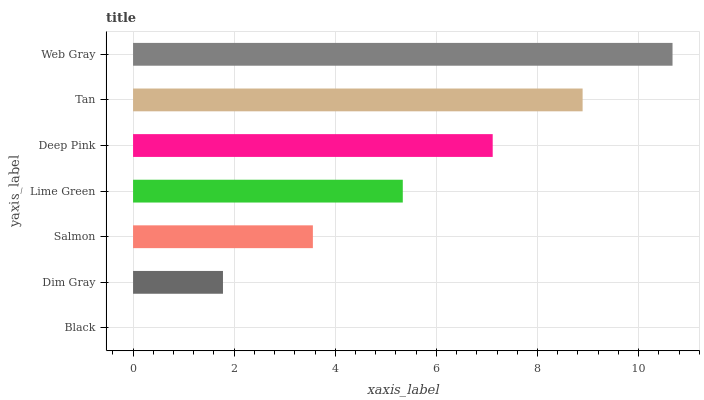Is Black the minimum?
Answer yes or no. Yes. Is Web Gray the maximum?
Answer yes or no. Yes. Is Dim Gray the minimum?
Answer yes or no. No. Is Dim Gray the maximum?
Answer yes or no. No. Is Dim Gray greater than Black?
Answer yes or no. Yes. Is Black less than Dim Gray?
Answer yes or no. Yes. Is Black greater than Dim Gray?
Answer yes or no. No. Is Dim Gray less than Black?
Answer yes or no. No. Is Lime Green the high median?
Answer yes or no. Yes. Is Lime Green the low median?
Answer yes or no. Yes. Is Black the high median?
Answer yes or no. No. Is Salmon the low median?
Answer yes or no. No. 